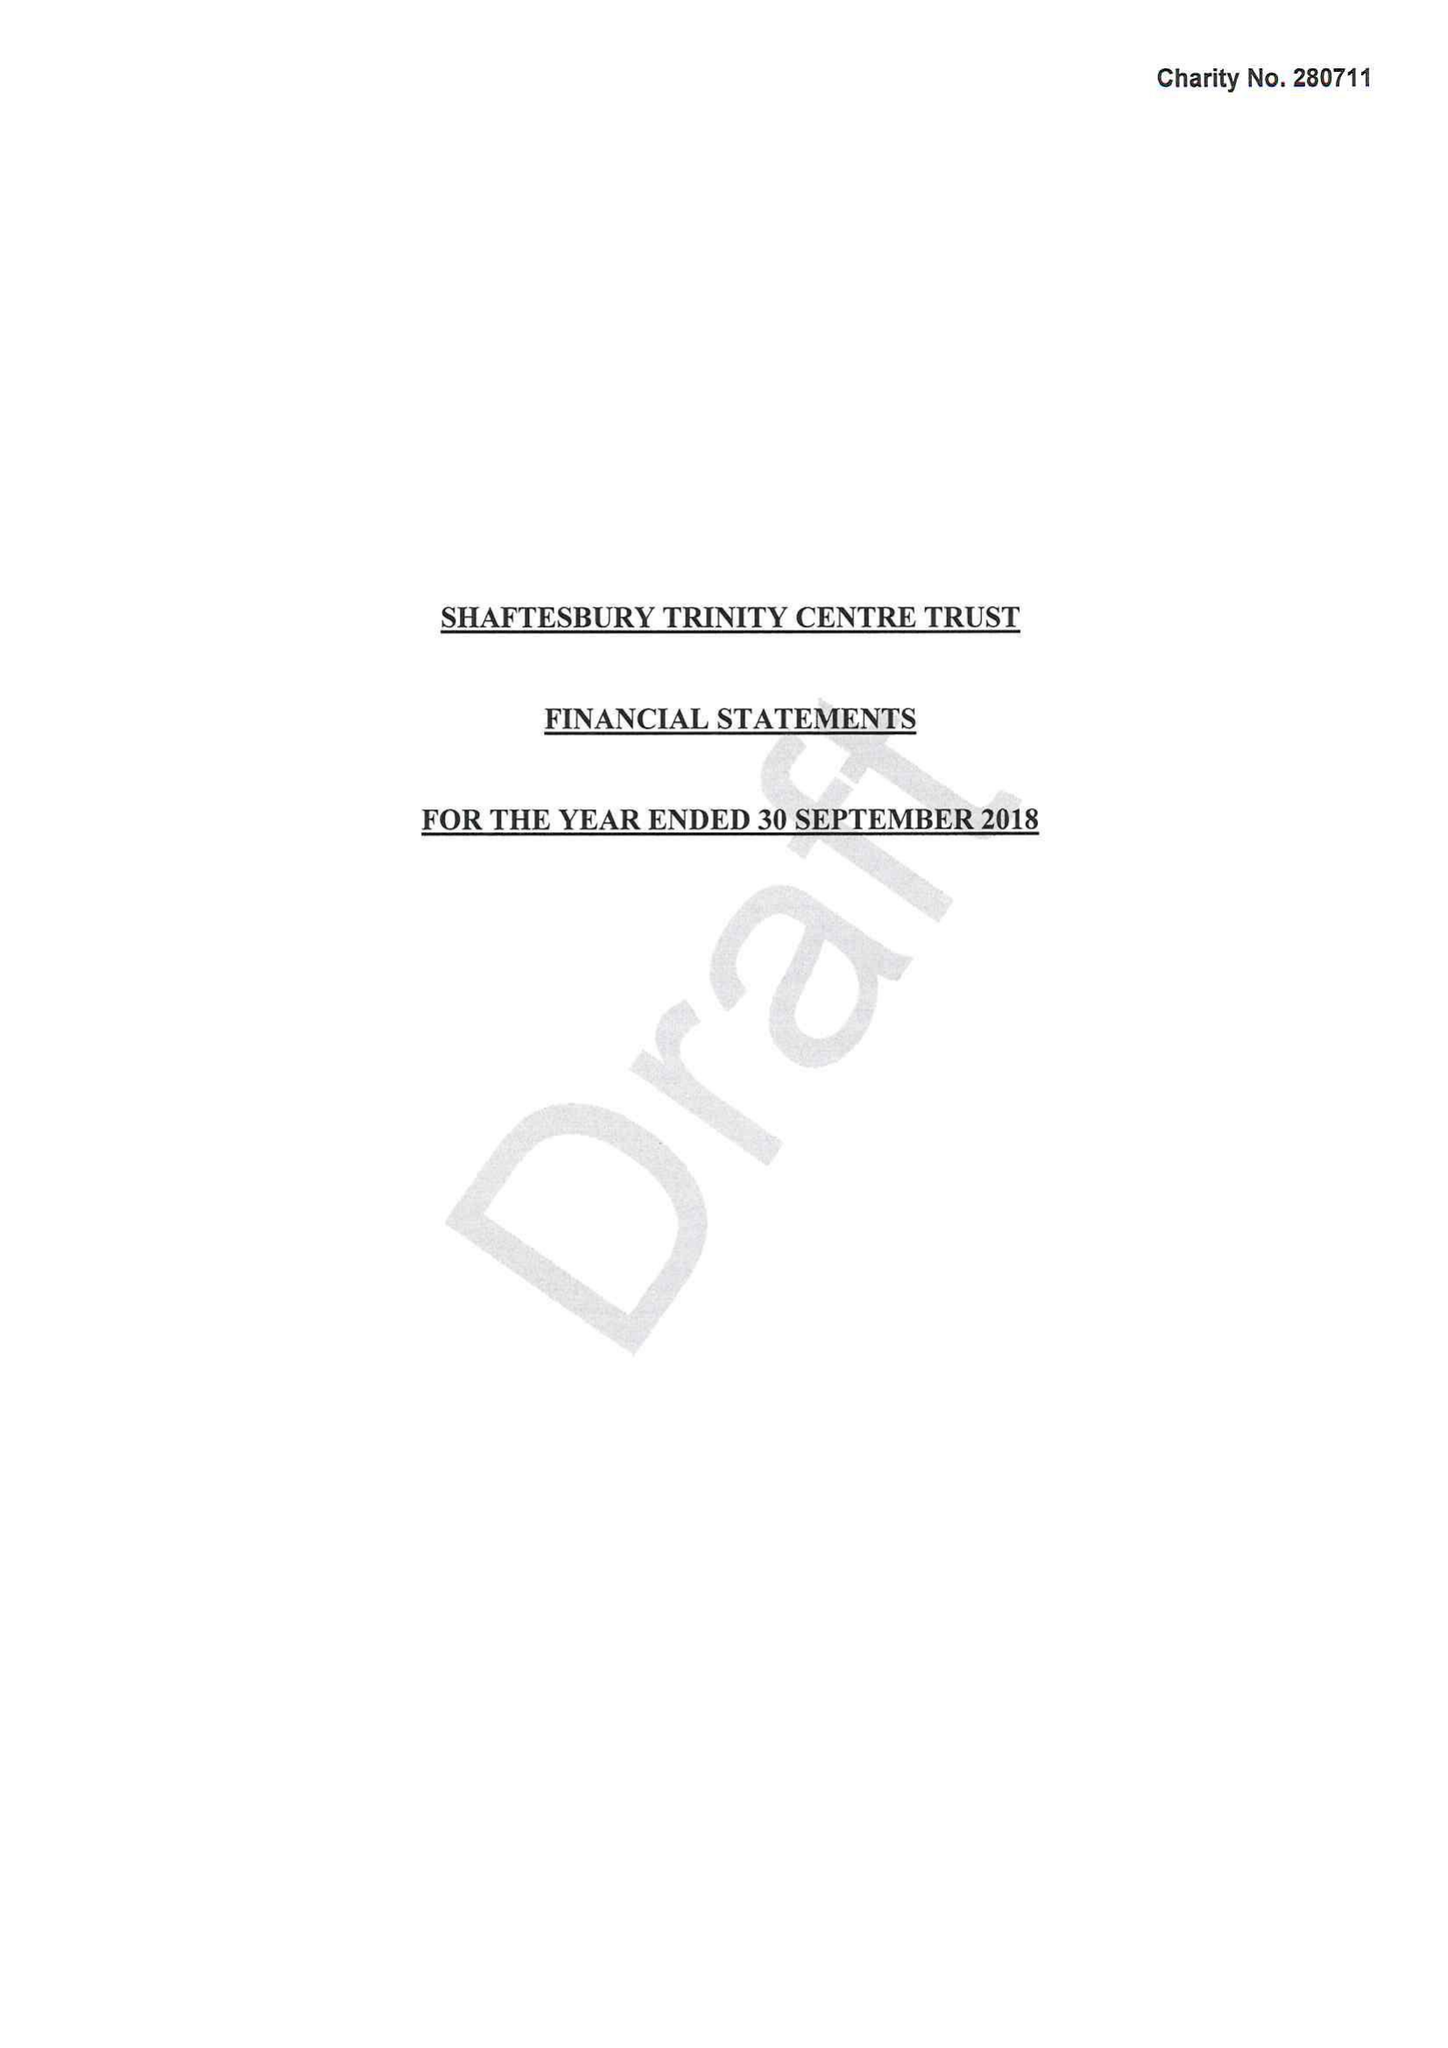What is the value for the address__postcode?
Answer the question using a single word or phrase. SP8 5JH 